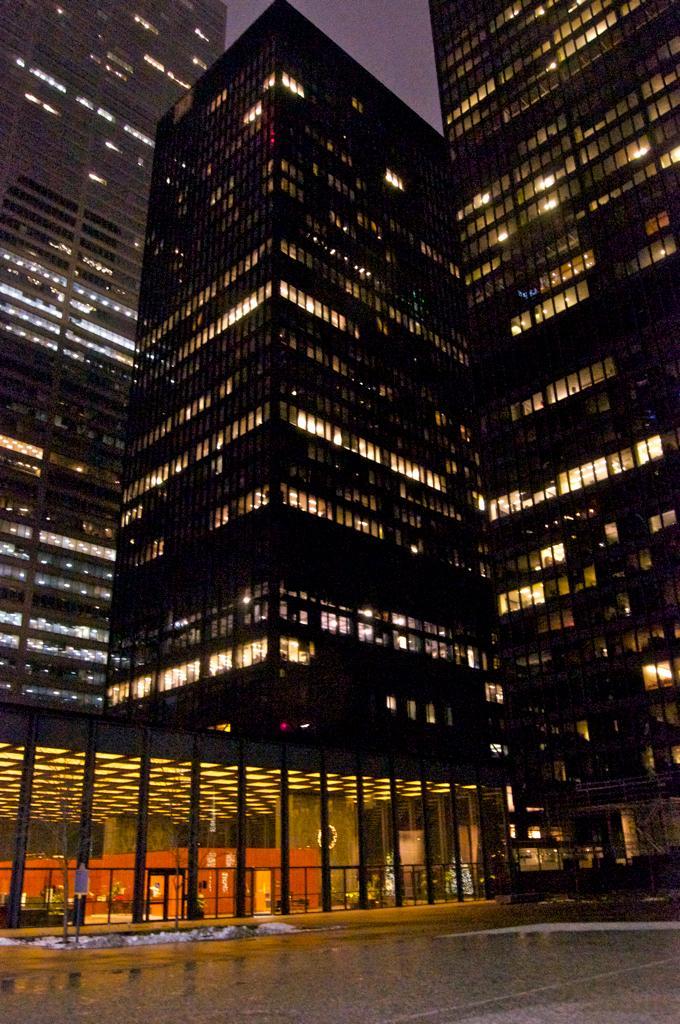In one or two sentences, can you explain what this image depicts? In this picture we can see few buildings and lights. 